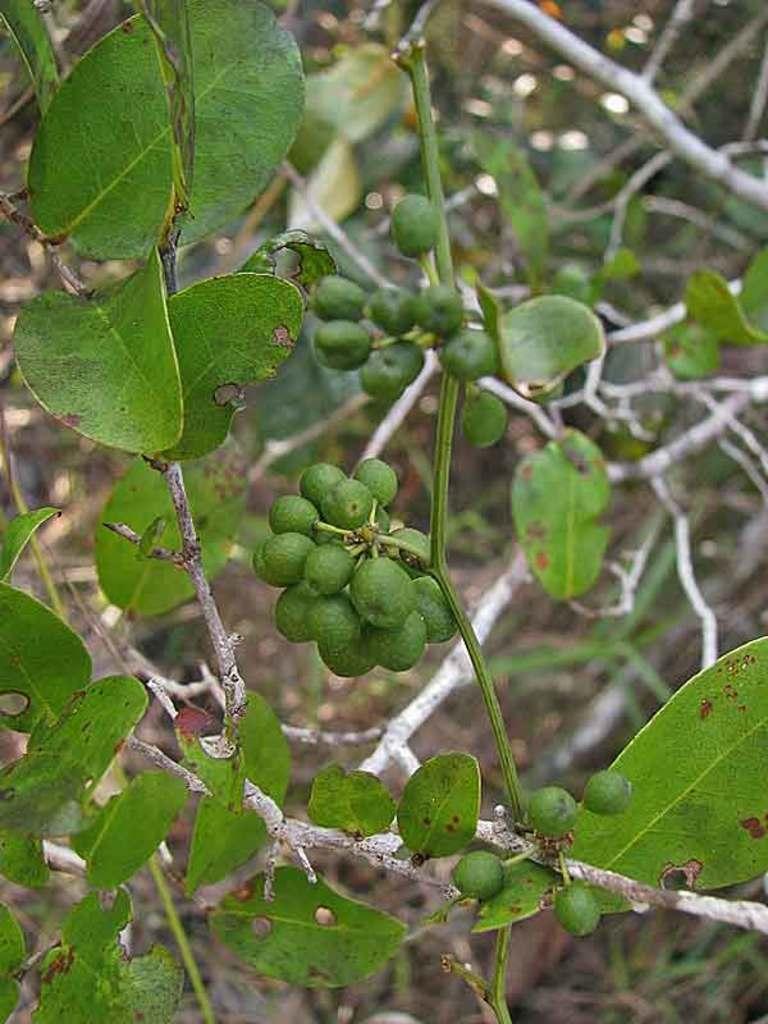Please provide a concise description of this image. In the image we can see leaves, tree branches and raw fruits. 